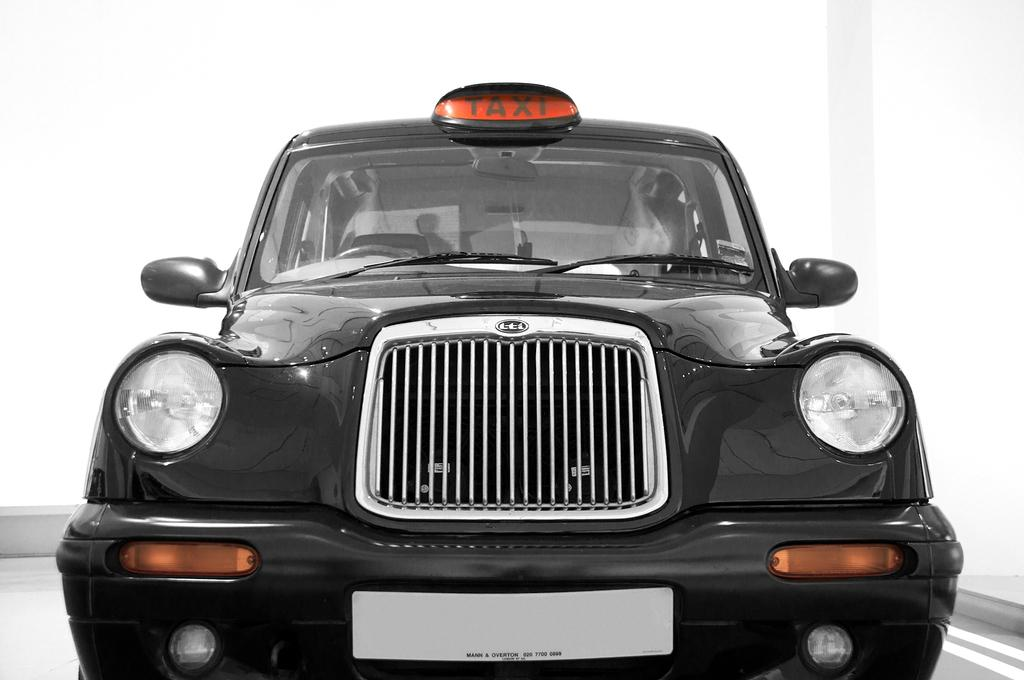What type of vehicle is in the image? There is a vehicle with a taxi plate in the image. What can be seen beneath the vehicle? The ground is visible in the image. What is present in the background of the image? There is a wall in the image. How many pies are being delivered by the taxi in the image? There is no indication of pies or delivery in the image; it simply shows a vehicle with a taxi plate. 